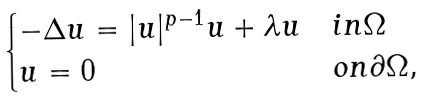<formula> <loc_0><loc_0><loc_500><loc_500>\begin{cases} - \Delta u = | u | ^ { p - 1 } u + \lambda u & i n \Omega \\ u = 0 & o n \partial \Omega , \end{cases}</formula> 